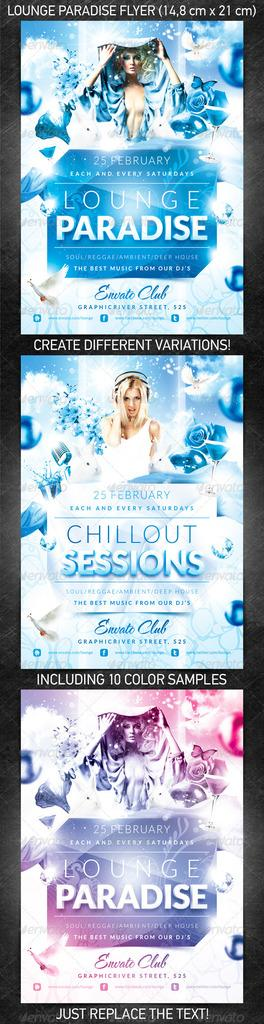<image>
Write a terse but informative summary of the picture. an item with Lounge Paradise written on it 